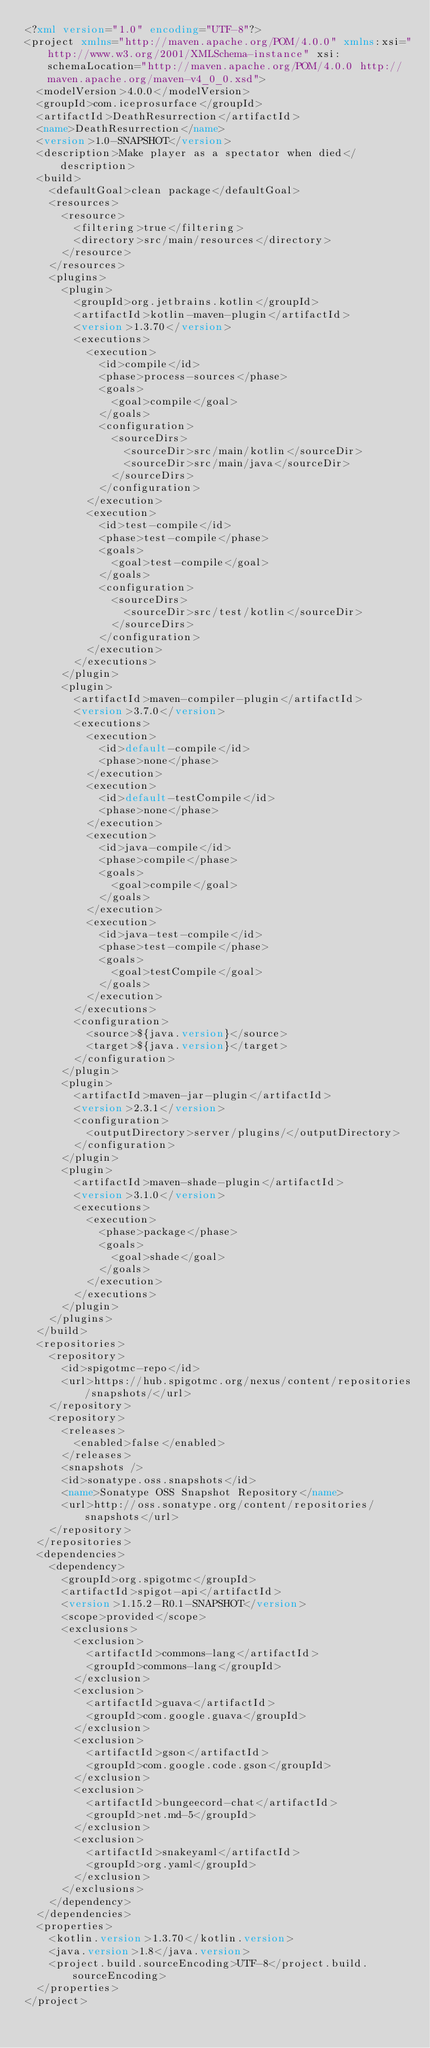Convert code to text. <code><loc_0><loc_0><loc_500><loc_500><_XML_><?xml version="1.0" encoding="UTF-8"?>
<project xmlns="http://maven.apache.org/POM/4.0.0" xmlns:xsi="http://www.w3.org/2001/XMLSchema-instance" xsi:schemaLocation="http://maven.apache.org/POM/4.0.0 http://maven.apache.org/maven-v4_0_0.xsd">
  <modelVersion>4.0.0</modelVersion>
  <groupId>com.iceprosurface</groupId>
  <artifactId>DeathResurrection</artifactId>
  <name>DeathResurrection</name>
  <version>1.0-SNAPSHOT</version>
  <description>Make player as a spectator when died</description>
  <build>
    <defaultGoal>clean package</defaultGoal>
    <resources>
      <resource>
        <filtering>true</filtering>
        <directory>src/main/resources</directory>
      </resource>
    </resources>
    <plugins>
      <plugin>
        <groupId>org.jetbrains.kotlin</groupId>
        <artifactId>kotlin-maven-plugin</artifactId>
        <version>1.3.70</version>
        <executions>
          <execution>
            <id>compile</id>
            <phase>process-sources</phase>
            <goals>
              <goal>compile</goal>
            </goals>
            <configuration>
              <sourceDirs>
                <sourceDir>src/main/kotlin</sourceDir>
                <sourceDir>src/main/java</sourceDir>
              </sourceDirs>
            </configuration>
          </execution>
          <execution>
            <id>test-compile</id>
            <phase>test-compile</phase>
            <goals>
              <goal>test-compile</goal>
            </goals>
            <configuration>
              <sourceDirs>
                <sourceDir>src/test/kotlin</sourceDir>
              </sourceDirs>
            </configuration>
          </execution>
        </executions>
      </plugin>
      <plugin>
        <artifactId>maven-compiler-plugin</artifactId>
        <version>3.7.0</version>
        <executions>
          <execution>
            <id>default-compile</id>
            <phase>none</phase>
          </execution>
          <execution>
            <id>default-testCompile</id>
            <phase>none</phase>
          </execution>
          <execution>
            <id>java-compile</id>
            <phase>compile</phase>
            <goals>
              <goal>compile</goal>
            </goals>
          </execution>
          <execution>
            <id>java-test-compile</id>
            <phase>test-compile</phase>
            <goals>
              <goal>testCompile</goal>
            </goals>
          </execution>
        </executions>
        <configuration>
          <source>${java.version}</source>
          <target>${java.version}</target>
        </configuration>
      </plugin>
      <plugin>
        <artifactId>maven-jar-plugin</artifactId>
        <version>2.3.1</version>
        <configuration>
          <outputDirectory>server/plugins/</outputDirectory>
        </configuration>
      </plugin>
      <plugin>
        <artifactId>maven-shade-plugin</artifactId>
        <version>3.1.0</version>
        <executions>
          <execution>
            <phase>package</phase>
            <goals>
              <goal>shade</goal>
            </goals>
          </execution>
        </executions>
      </plugin>
    </plugins>
  </build>
  <repositories>
    <repository>
      <id>spigotmc-repo</id>
      <url>https://hub.spigotmc.org/nexus/content/repositories/snapshots/</url>
    </repository>
    <repository>
      <releases>
        <enabled>false</enabled>
      </releases>
      <snapshots />
      <id>sonatype.oss.snapshots</id>
      <name>Sonatype OSS Snapshot Repository</name>
      <url>http://oss.sonatype.org/content/repositories/snapshots</url>
    </repository>
  </repositories>
  <dependencies>
    <dependency>
      <groupId>org.spigotmc</groupId>
      <artifactId>spigot-api</artifactId>
      <version>1.15.2-R0.1-SNAPSHOT</version>
      <scope>provided</scope>
      <exclusions>
        <exclusion>
          <artifactId>commons-lang</artifactId>
          <groupId>commons-lang</groupId>
        </exclusion>
        <exclusion>
          <artifactId>guava</artifactId>
          <groupId>com.google.guava</groupId>
        </exclusion>
        <exclusion>
          <artifactId>gson</artifactId>
          <groupId>com.google.code.gson</groupId>
        </exclusion>
        <exclusion>
          <artifactId>bungeecord-chat</artifactId>
          <groupId>net.md-5</groupId>
        </exclusion>
        <exclusion>
          <artifactId>snakeyaml</artifactId>
          <groupId>org.yaml</groupId>
        </exclusion>
      </exclusions>
    </dependency>
  </dependencies>
  <properties>
    <kotlin.version>1.3.70</kotlin.version>
    <java.version>1.8</java.version>
    <project.build.sourceEncoding>UTF-8</project.build.sourceEncoding>
  </properties>
</project>

</code> 